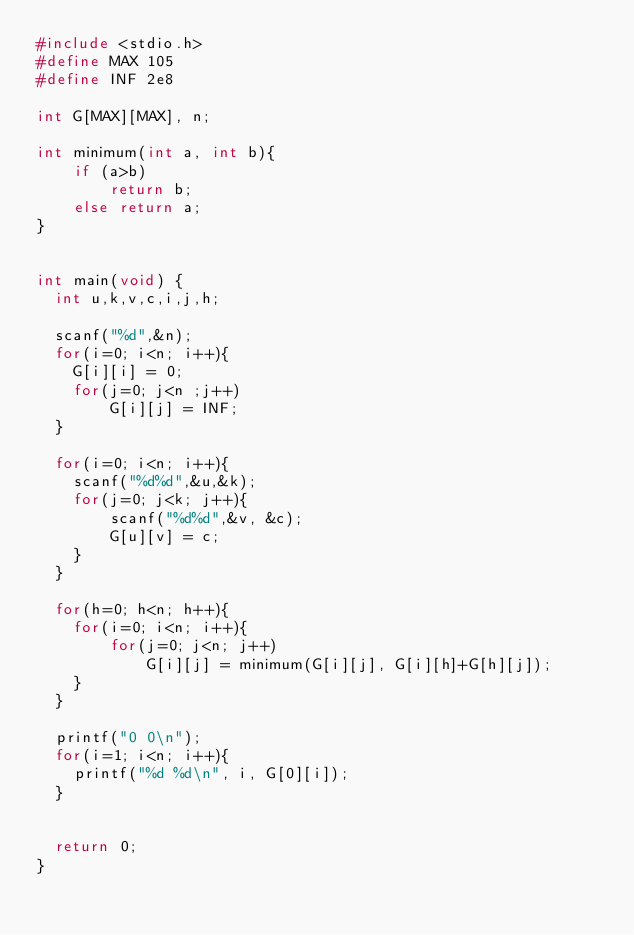Convert code to text. <code><loc_0><loc_0><loc_500><loc_500><_C_>#include <stdio.h>
#define MAX 105
#define INF 2e8

int G[MAX][MAX], n;

int minimum(int a, int b){
	if (a>b)
		return b;
	else return a;
}


int main(void) {
  int u,k,v,c,i,j,h;
 
  scanf("%d",&n);
  for(i=0; i<n; i++){
  	G[i][i] = 0;
	for(j=0; j<n ;j++)
  		G[i][j] = INF;
  }

  for(i=0; i<n; i++){
	scanf("%d%d",&u,&k);
	for(j=0; j<k; j++){
  		scanf("%d%d",&v, &c);
  		G[u][v] = c;
	}
  }

  for(h=0; h<n; h++){  
    for(i=0; i<n; i++){
		for(j=0; j<n; j++)
			G[i][j] = minimum(G[i][j], G[i][h]+G[h][j]);
  	}
  }
  
  printf("0 0\n");
  for(i=1; i<n; i++){
	printf("%d %d\n", i, G[0][i]);
  }
	

  return 0;
}
</code> 